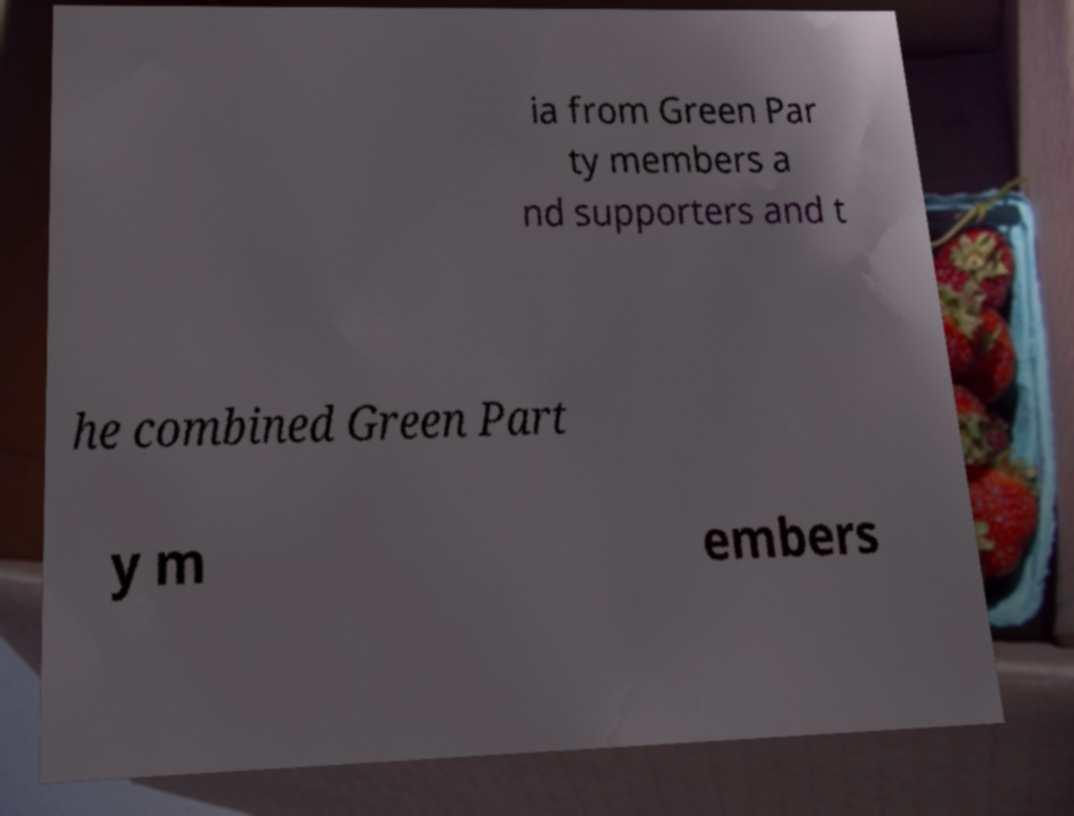For documentation purposes, I need the text within this image transcribed. Could you provide that? ia from Green Par ty members a nd supporters and t he combined Green Part y m embers 